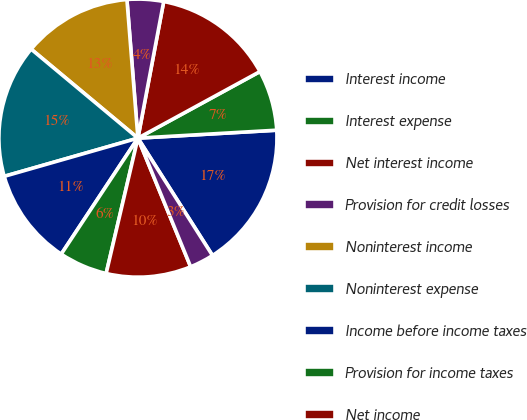Convert chart to OTSL. <chart><loc_0><loc_0><loc_500><loc_500><pie_chart><fcel>Interest income<fcel>Interest expense<fcel>Net interest income<fcel>Provision for credit losses<fcel>Noninterest income<fcel>Noninterest expense<fcel>Income before income taxes<fcel>Provision for income taxes<fcel>Net income<fcel>Dividends on preferred shares<nl><fcel>16.9%<fcel>7.04%<fcel>14.08%<fcel>4.23%<fcel>12.68%<fcel>15.49%<fcel>11.27%<fcel>5.63%<fcel>9.86%<fcel>2.82%<nl></chart> 